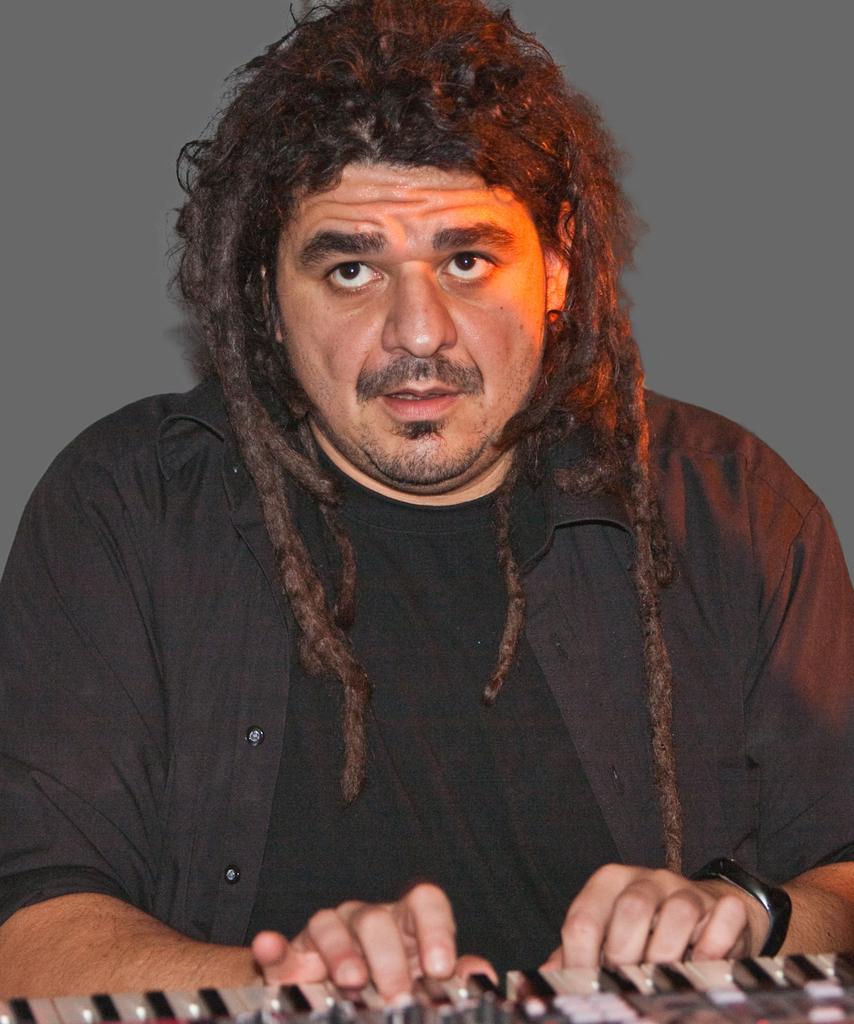In one or two sentences, can you explain what this image depicts? There is one person present in the middle of this image. We can see a piano at the bottom of this image and there is a wall in the background. 